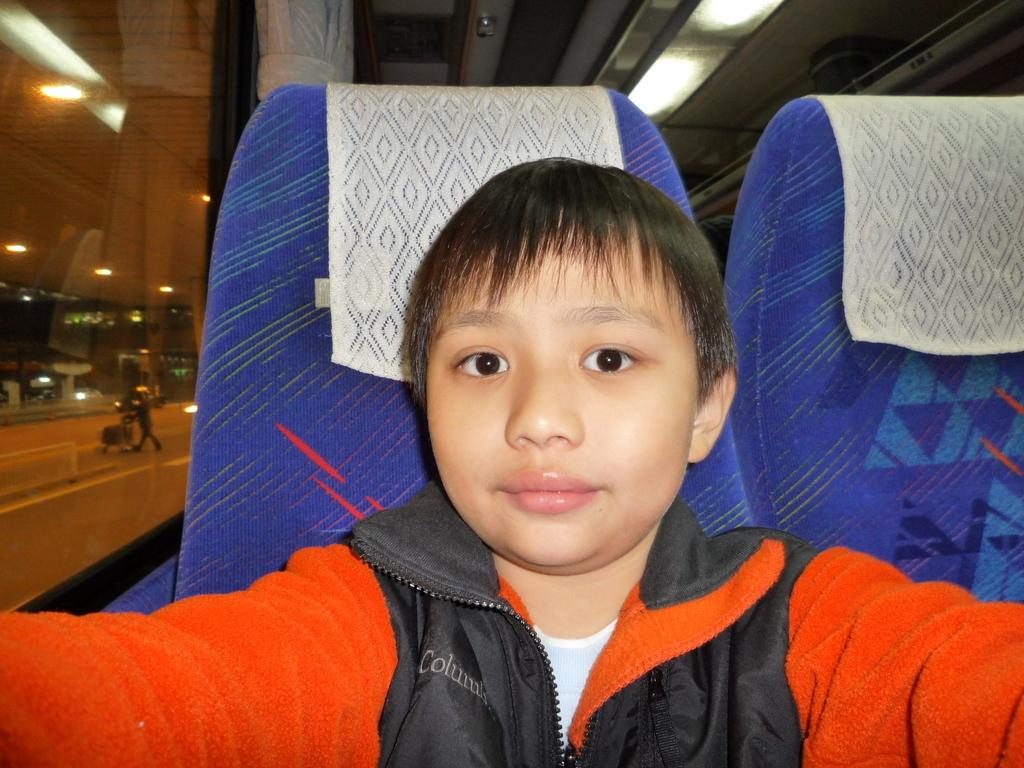Who is the main subject in the picture? There is a boy in the picture. What is the boy wearing? The boy is wearing a jacket. What is the boy doing in the picture? The boy is sitting on a seat. What can be seen in the background of the picture? There are lights visible in the background, and there is a person walking on the road. What industry does the boy's father work in? There is no mention of the boy's father in the image, so it is impossible to determine the industry he works in. 